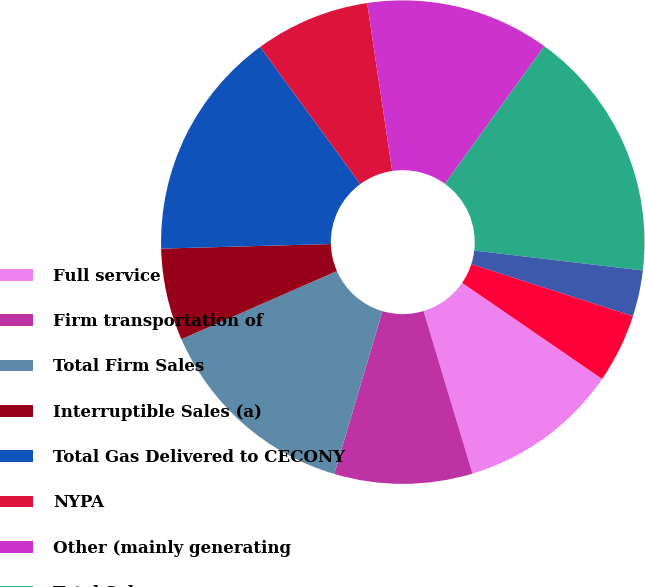<chart> <loc_0><loc_0><loc_500><loc_500><pie_chart><fcel>Full service<fcel>Firm transportation of<fcel>Total Firm Sales<fcel>Interruptible Sales (a)<fcel>Total Gas Delivered to CECONY<fcel>NYPA<fcel>Other (mainly generating<fcel>Total Sales<fcel>Interruptible Sales<fcel>Other operating revenues<nl><fcel>10.77%<fcel>9.23%<fcel>13.85%<fcel>6.15%<fcel>15.38%<fcel>7.69%<fcel>12.31%<fcel>16.92%<fcel>3.08%<fcel>4.62%<nl></chart> 